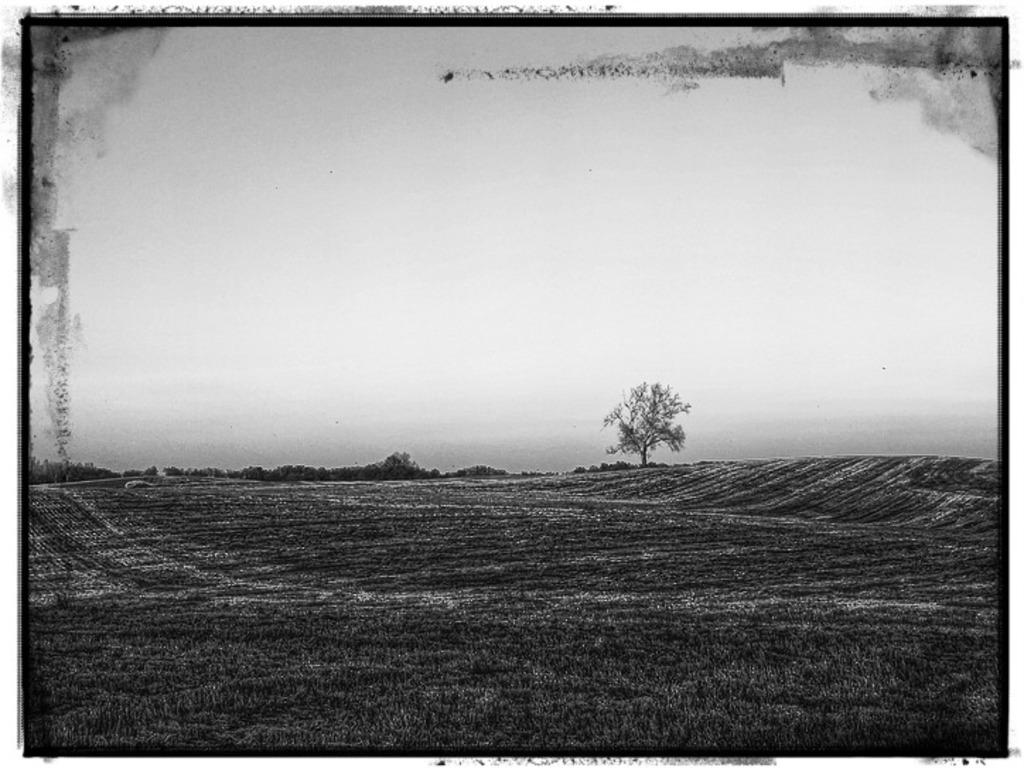What is the color scheme of the image? The image is black and white. What is the main subject in the middle of the image? There is a tree in the middle of the image. What type of vegetation is at the bottom of the image? There is grass at the bottom of the image. How many minutes does the minister spend on the property in the image? There is no minister or property present in the image, so it is not possible to determine how many minutes they might spend there. 